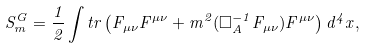Convert formula to latex. <formula><loc_0><loc_0><loc_500><loc_500>S _ { m } ^ { G } = \frac { 1 } { 2 } \int t r \left ( F _ { \mu \nu } F ^ { \mu \nu } + m ^ { 2 } ( \square ^ { - 1 } _ { A } F _ { \mu \nu } ) F ^ { \mu \nu } \right ) d ^ { 4 } x ,</formula> 